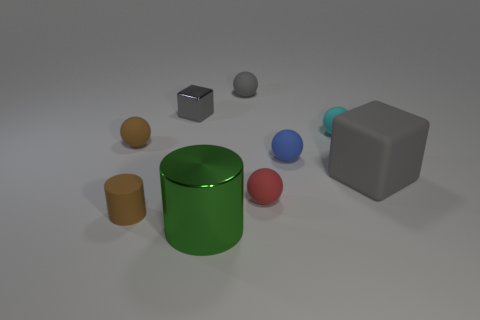Do the gray matte cube and the cyan rubber object have the same size?
Make the answer very short. No. What number of tiny gray matte objects are on the left side of the brown rubber cylinder?
Your response must be concise. 0. How many things are blocks that are to the right of the tiny cyan rubber thing or balls?
Ensure brevity in your answer.  6. Is the number of tiny matte balls in front of the big gray cube greater than the number of blue objects that are in front of the green shiny cylinder?
Your response must be concise. Yes. What is the size of the sphere that is the same color as the small rubber cylinder?
Give a very brief answer. Small. There is a green object; is its size the same as the shiny thing behind the green thing?
Give a very brief answer. No. How many cubes are small purple rubber objects or gray shiny things?
Ensure brevity in your answer.  1. What is the size of the cyan sphere that is the same material as the brown ball?
Your response must be concise. Small. There is a metallic object that is behind the green thing; is its size the same as the brown object behind the large matte block?
Offer a very short reply. Yes. What number of objects are either metal cubes or green matte objects?
Provide a succinct answer. 1. 